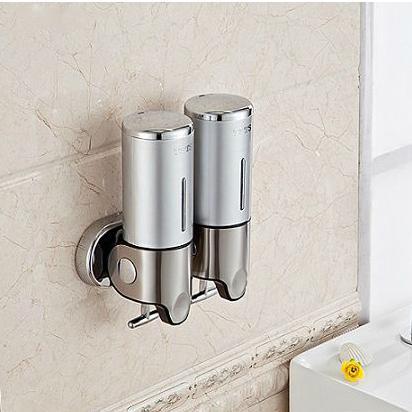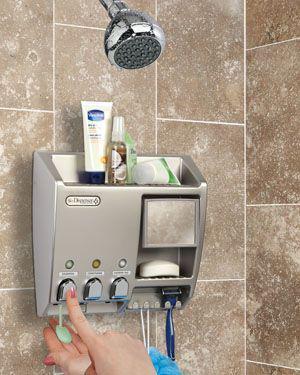The first image is the image on the left, the second image is the image on the right. Evaluate the accuracy of this statement regarding the images: "One of the images shows a dispenser for two liquids, lotions, or soaps.". Is it true? Answer yes or no. Yes. The first image is the image on the left, the second image is the image on the right. Given the left and right images, does the statement "In one image there are two dispensers with a silver base." hold true? Answer yes or no. Yes. 